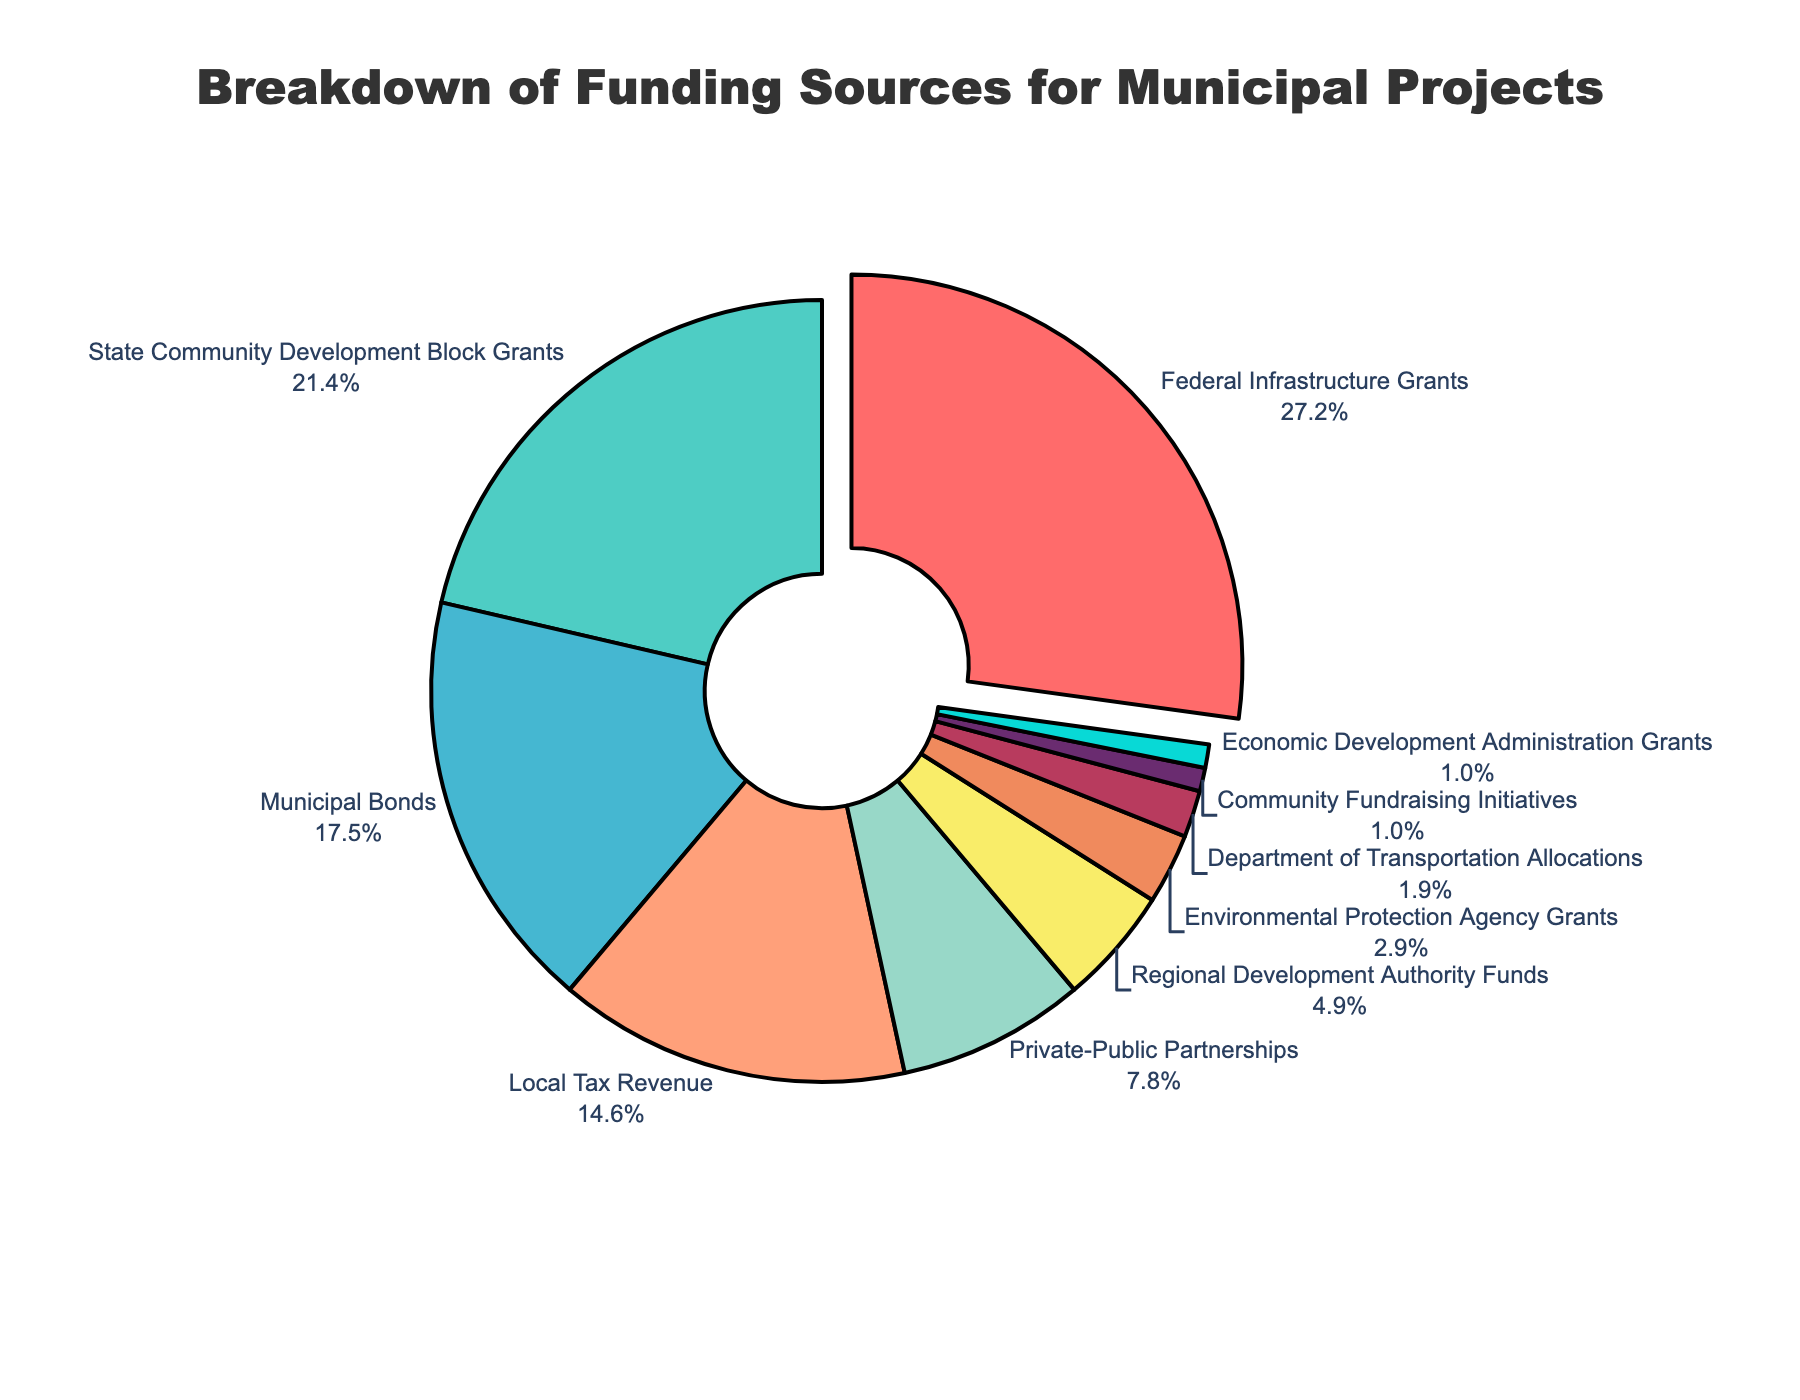What is the largest funding source for municipal projects? The largest funding source is where the pull effect is applied, which is seen on the 'Federal Infrastructure Grants' segment that is separated slightly from the others in the pie chart by a gap.
Answer: Federal Infrastructure Grants What is the sum of the percentages for Federal Infrastructure Grants and State Community Development Block Grants? The Federal Infrastructure Grants contribute 28% and the State Community Development Block Grants contribute 22%. So, 28% + 22% = 50%.
Answer: 50% Which funding sources contribute equally to municipal projects? The pie chart shows two segments of the same size at the smallest end, which are 'Community Fundraising Initiatives' and 'Economic Development Administration Grants', each contributing 1%.
Answer: Community Fundraising Initiatives, Economic Development Administration Grants Which two funding sources together contribute more than Municipal Bonds? Municipal Bonds contribute 18%. While various combinations are possible, one example is 'Local Tax Revenue' with 15% and 'Private-Public Partnerships' with 8%. Their sum is 15% + 8% = 23%, which is greater than 18%.
Answer: Local Tax Revenue, Private-Public Partnerships What is the total percentage contribution from private entities (Private-Public Partnerships and Community Fundraising Initiatives)? Private-Public Partnerships contribute 8% and Community Fundraising Initiatives contribute 1%. Adding these together, 8% + 1% = 9%.
Answer: 9% Which segment is the smallest and what is its color? The smallest segment is 'Economic Development Administration Grants' which contributes 1%. The color of this segment is light blue.
Answer: Economic Development Administration Grants, light blue How many funding sources contribute less than 10% each? The pie chart segments contributing less than 10% are 'Private-Public Partnerships' (8%), 'Regional Development Authority Funds' (5%), 'Environmental Protection Agency Grants' (3%), 'Department of Transportation Allocations' (2%), 'Community Fundraising Initiatives' (1%), and 'Economic Development Administration Grants' (1%). There are 6 such segments.
Answer: 6 Which funding source has the smallest pull effect applied, and what is its contribution? The segment 'Federal Infrastructure Grants' has the largest pull effect applied, indicating it's the highest contributor. The smallest possible pull effect is for segments with no pull applied, such as 'Economic Development Administration Grants' with a 1% contribution.
Answer: Economic Development Administration Grants, 1% What is the difference in percentage between the largest and smallest funding sources? The largest funding source is 'Federal Infrastructure Grants' with 28%, and the smallest funding sources are 'Community Fundraising Initiatives' and 'Economic Development Administration Grants' with 1% each. The difference is 28% - 1% = 27%.
Answer: 27% 